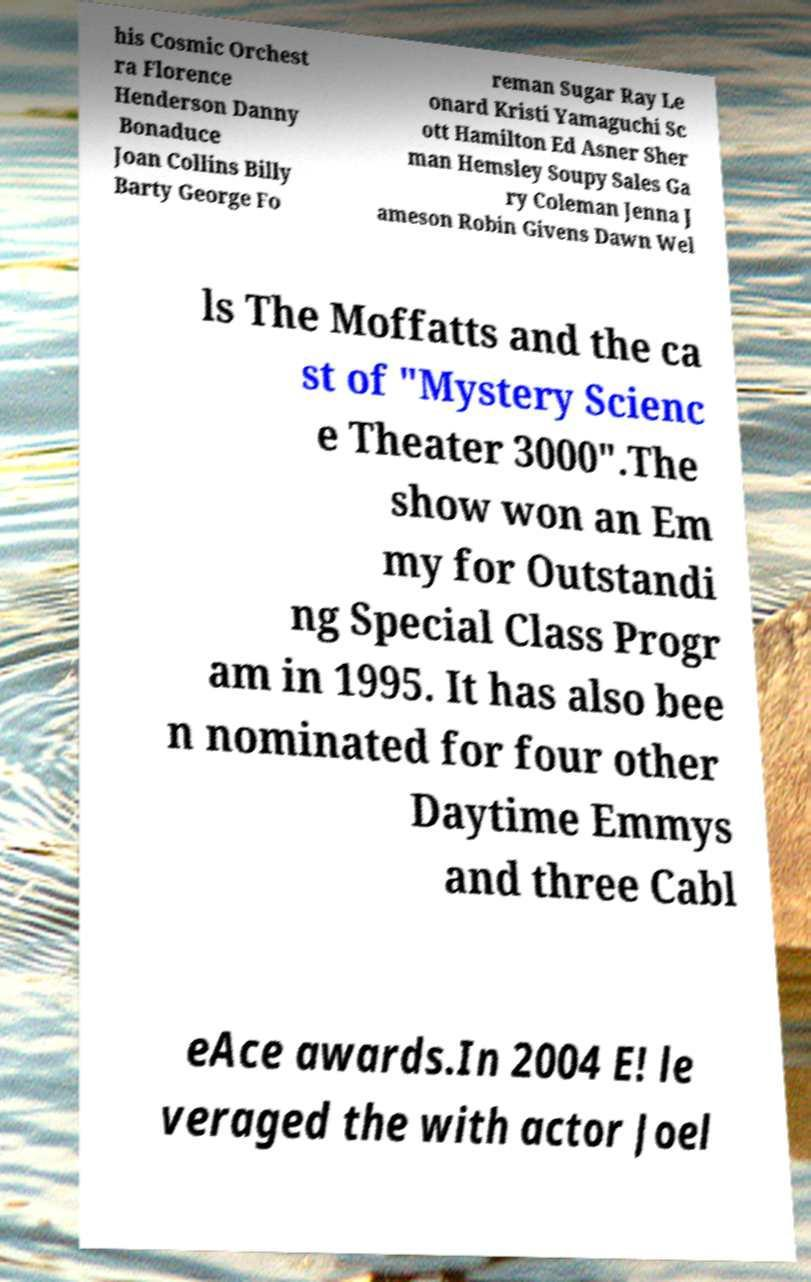Can you accurately transcribe the text from the provided image for me? his Cosmic Orchest ra Florence Henderson Danny Bonaduce Joan Collins Billy Barty George Fo reman Sugar Ray Le onard Kristi Yamaguchi Sc ott Hamilton Ed Asner Sher man Hemsley Soupy Sales Ga ry Coleman Jenna J ameson Robin Givens Dawn Wel ls The Moffatts and the ca st of "Mystery Scienc e Theater 3000".The show won an Em my for Outstandi ng Special Class Progr am in 1995. It has also bee n nominated for four other Daytime Emmys and three Cabl eAce awards.In 2004 E! le veraged the with actor Joel 